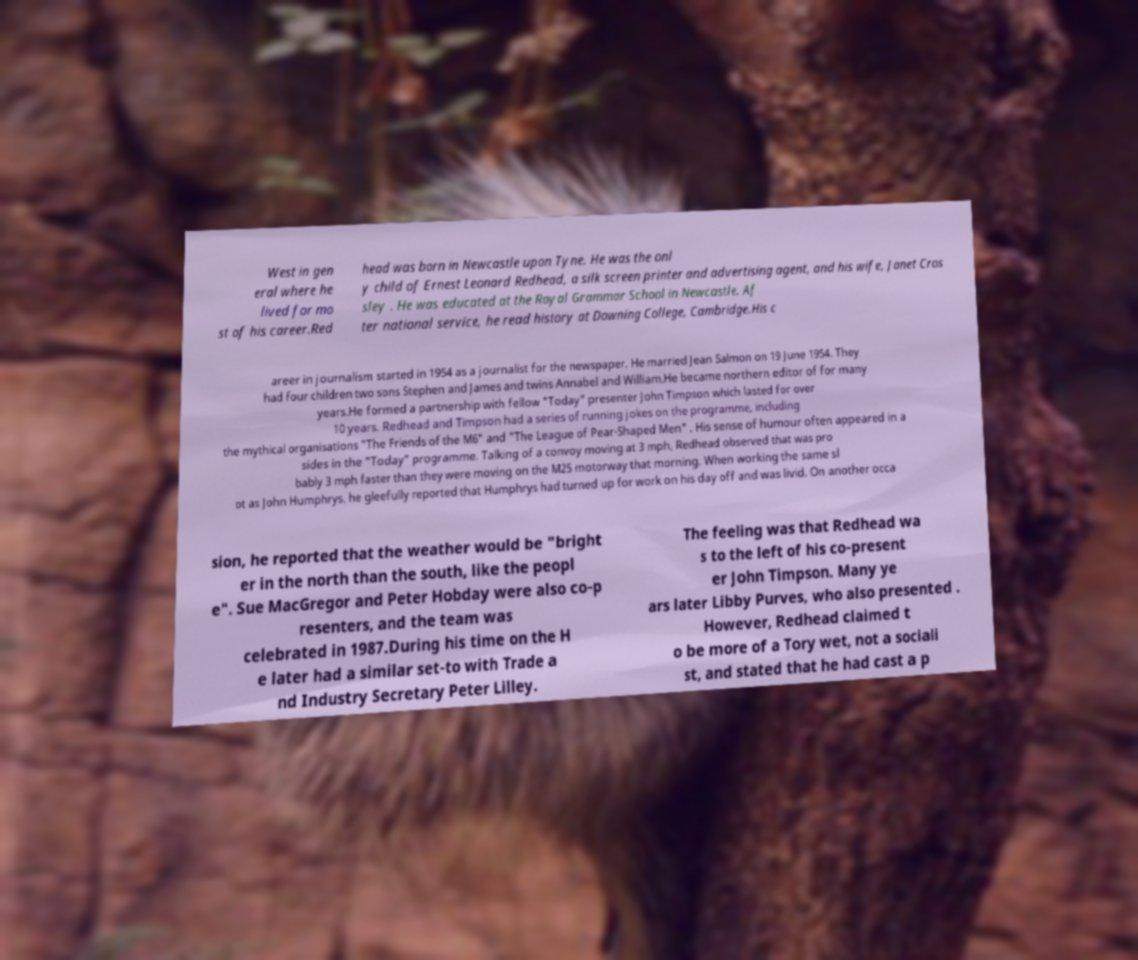Can you read and provide the text displayed in the image?This photo seems to have some interesting text. Can you extract and type it out for me? West in gen eral where he lived for mo st of his career.Red head was born in Newcastle upon Tyne. He was the onl y child of Ernest Leonard Redhead, a silk screen printer and advertising agent, and his wife, Janet Cros sley . He was educated at the Royal Grammar School in Newcastle. Af ter national service, he read history at Downing College, Cambridge.His c areer in journalism started in 1954 as a journalist for the newspaper. He married Jean Salmon on 19 June 1954. They had four children two sons Stephen and James and twins Annabel and William.He became northern editor of for many years.He formed a partnership with fellow "Today" presenter John Timpson which lasted for over 10 years. Redhead and Timpson had a series of running jokes on the programme, including the mythical organisations "The Friends of the M6" and "The League of Pear-Shaped Men" . His sense of humour often appeared in a sides in the "Today" programme. Talking of a convoy moving at 3 mph, Redhead observed that was pro bably 3 mph faster than they were moving on the M25 motorway that morning. When working the same sl ot as John Humphrys, he gleefully reported that Humphrys had turned up for work on his day off and was livid. On another occa sion, he reported that the weather would be "bright er in the north than the south, like the peopl e". Sue MacGregor and Peter Hobday were also co-p resenters, and the team was celebrated in 1987.During his time on the H e later had a similar set-to with Trade a nd Industry Secretary Peter Lilley. The feeling was that Redhead wa s to the left of his co-present er John Timpson. Many ye ars later Libby Purves, who also presented . However, Redhead claimed t o be more of a Tory wet, not a sociali st, and stated that he had cast a p 